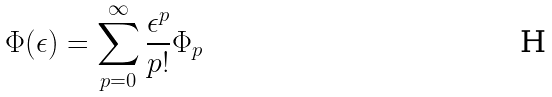Convert formula to latex. <formula><loc_0><loc_0><loc_500><loc_500>\Phi ( \epsilon ) = \sum _ { p = 0 } ^ { \infty } \frac { \epsilon ^ { p } } { p ! } \Phi _ { p }</formula> 